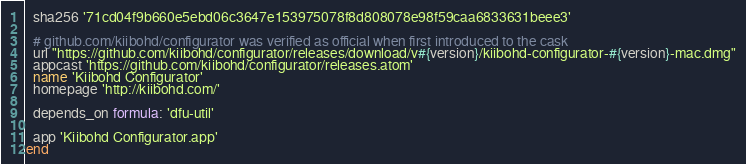Convert code to text. <code><loc_0><loc_0><loc_500><loc_500><_Ruby_>  sha256 '71cd04f9b660e5ebd06c3647e153975078f8d808078e98f59caa6833631beee3'

  # github.com/kiibohd/configurator was verified as official when first introduced to the cask
  url "https://github.com/kiibohd/configurator/releases/download/v#{version}/kiibohd-configurator-#{version}-mac.dmg"
  appcast 'https://github.com/kiibohd/configurator/releases.atom'
  name 'Kiibohd Configurator'
  homepage 'http://kiibohd.com/'

  depends_on formula: 'dfu-util'

  app 'Kiibohd Configurator.app'
end
</code> 